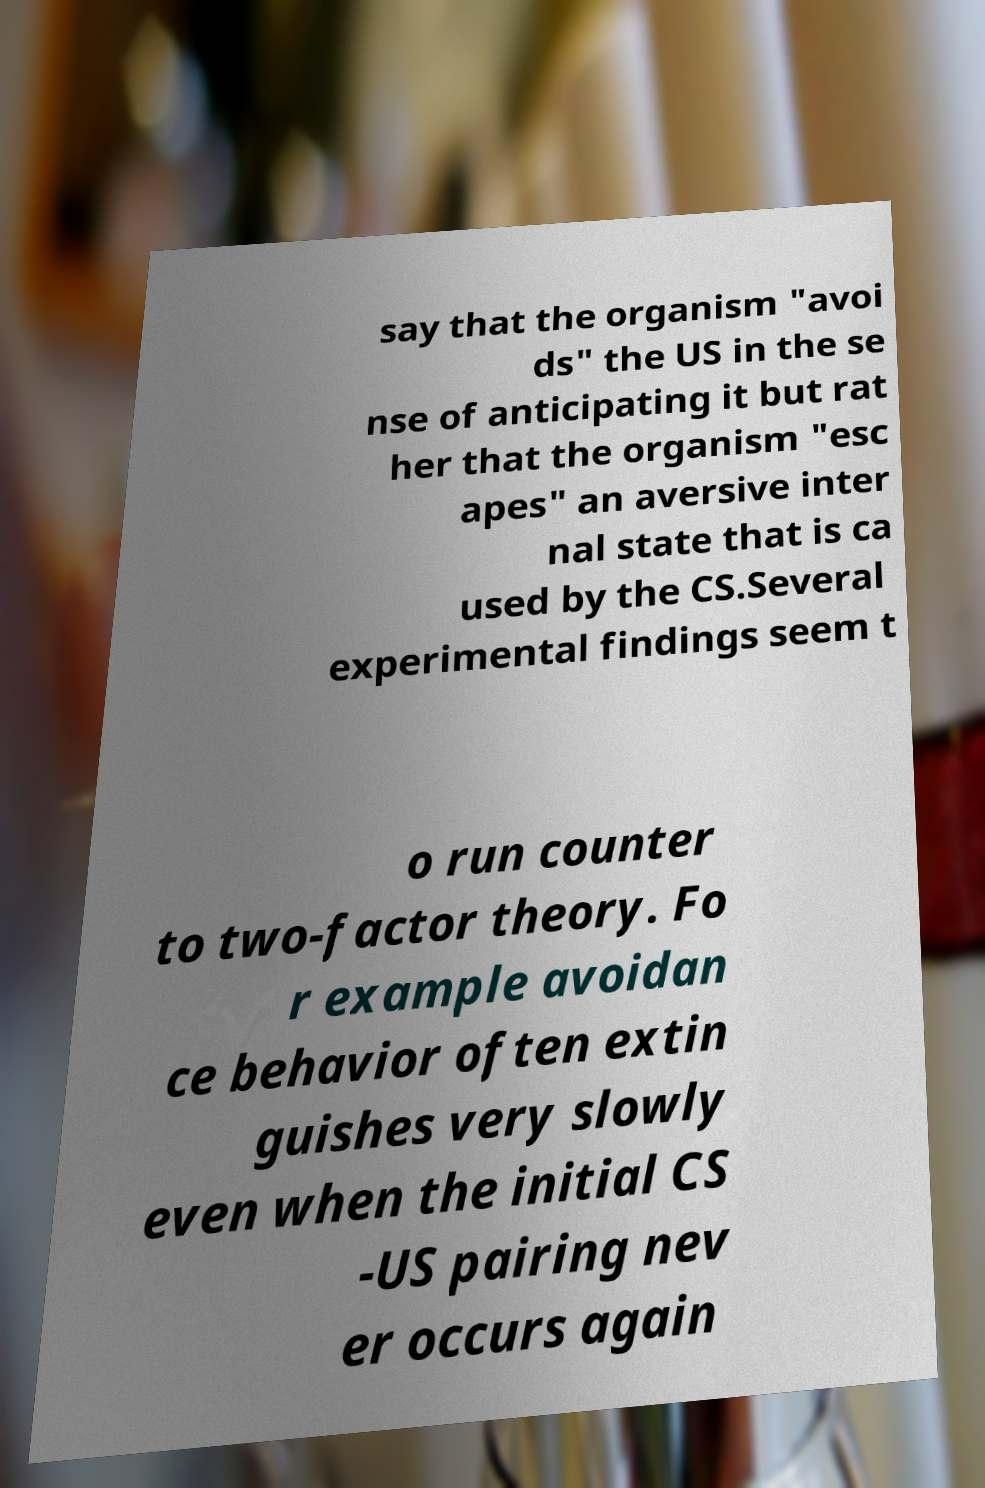Please identify and transcribe the text found in this image. say that the organism "avoi ds" the US in the se nse of anticipating it but rat her that the organism "esc apes" an aversive inter nal state that is ca used by the CS.Several experimental findings seem t o run counter to two-factor theory. Fo r example avoidan ce behavior often extin guishes very slowly even when the initial CS -US pairing nev er occurs again 